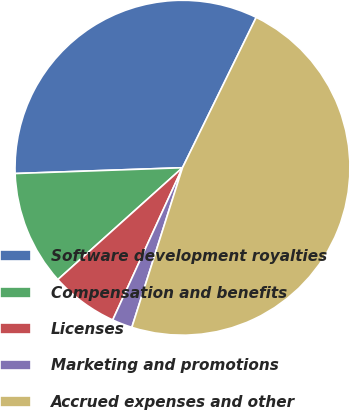Convert chart to OTSL. <chart><loc_0><loc_0><loc_500><loc_500><pie_chart><fcel>Software development royalties<fcel>Compensation and benefits<fcel>Licenses<fcel>Marketing and promotions<fcel>Accrued expenses and other<nl><fcel>32.81%<fcel>11.09%<fcel>6.52%<fcel>1.95%<fcel>47.64%<nl></chart> 